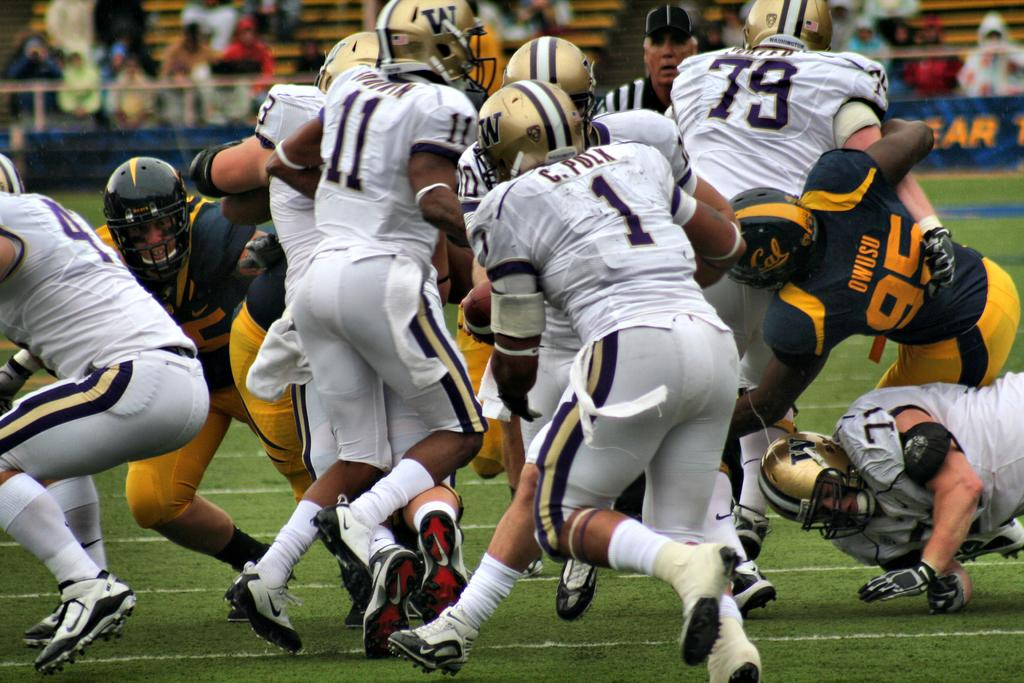What are the people in the image wearing? The people in the image are wearing sports dress. What are the people in the image doing? The people appear to be playing. Can you describe the background of the image? There are people in the background of the image. How would you describe the quality of the image? The image is blurred. What type of pencil can be seen in the image? There is no pencil present in the image. How does the twist affect the game being played in the image? There is no twist mentioned or depicted in the image, and therefore it cannot affect the game being played. 